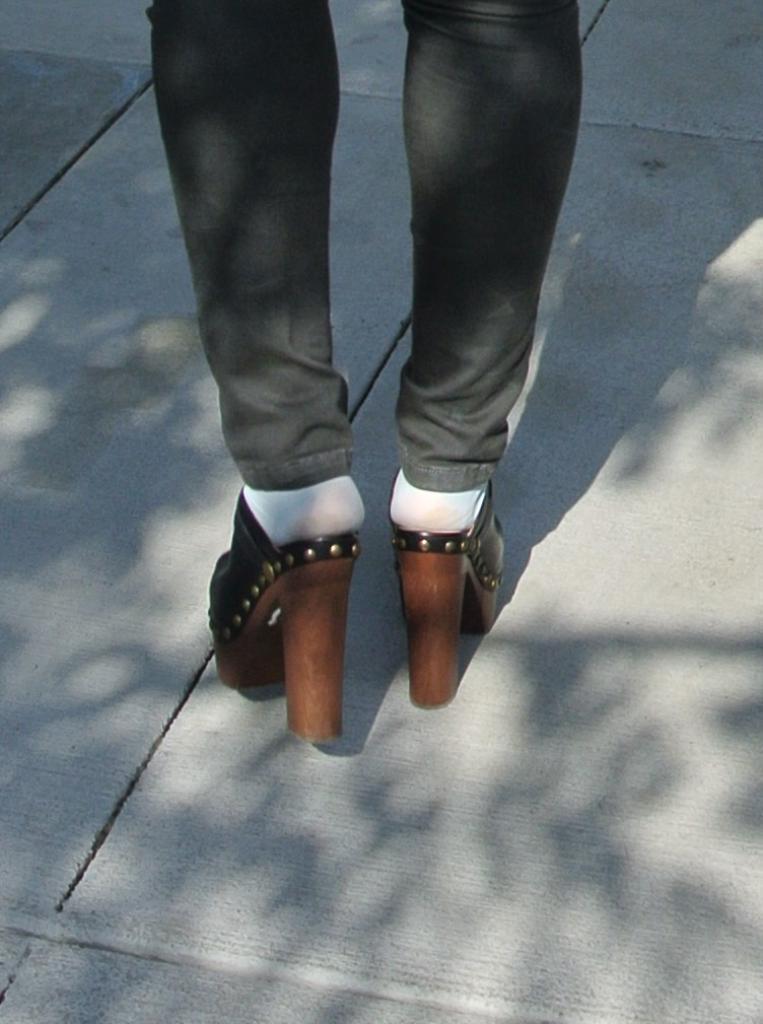Could you give a brief overview of what you see in this image? In this image there is person legś, the person is wearing high heels. 